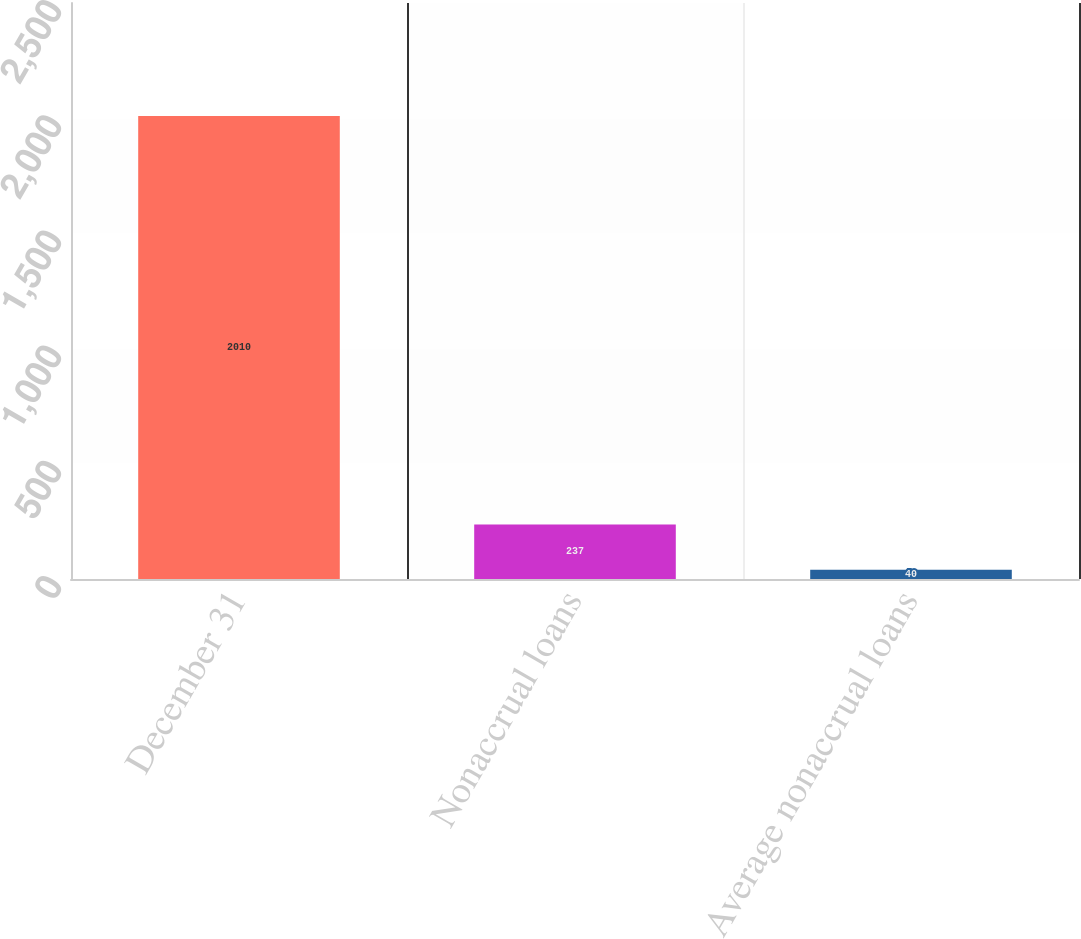Convert chart to OTSL. <chart><loc_0><loc_0><loc_500><loc_500><bar_chart><fcel>December 31<fcel>Nonaccrual loans<fcel>Average nonaccrual loans<nl><fcel>2010<fcel>237<fcel>40<nl></chart> 